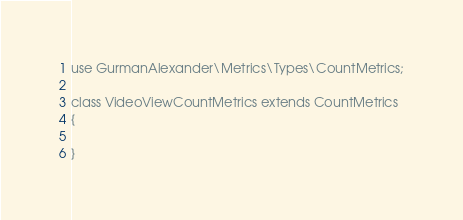<code> <loc_0><loc_0><loc_500><loc_500><_PHP_>
use GurmanAlexander\Metrics\Types\CountMetrics;

class VideoViewCountMetrics extends CountMetrics
{

}
</code> 